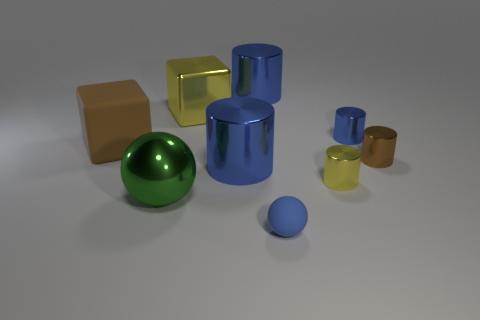There is a thing that is the same color as the rubber block; what is its size?
Give a very brief answer. Small. Is the color of the cube behind the brown rubber object the same as the big metal cylinder behind the yellow metallic cube?
Offer a very short reply. No. The matte thing that is the same size as the yellow cube is what shape?
Offer a terse response. Cube. What number of objects are either large metallic things that are in front of the rubber cube or yellow metallic objects right of the yellow metal cube?
Provide a short and direct response. 3. Is the number of brown blocks less than the number of matte objects?
Your answer should be compact. Yes. What material is the brown thing that is the same size as the green shiny thing?
Your response must be concise. Rubber. Does the blue rubber sphere in front of the large rubber thing have the same size as the metallic cylinder that is behind the metal block?
Offer a terse response. No. Are there any tiny yellow cylinders made of the same material as the big green thing?
Offer a very short reply. Yes. What number of objects are either balls in front of the green metallic ball or cyan cylinders?
Give a very brief answer. 1. Is the large cylinder in front of the tiny brown cylinder made of the same material as the brown cylinder?
Your answer should be very brief. Yes. 